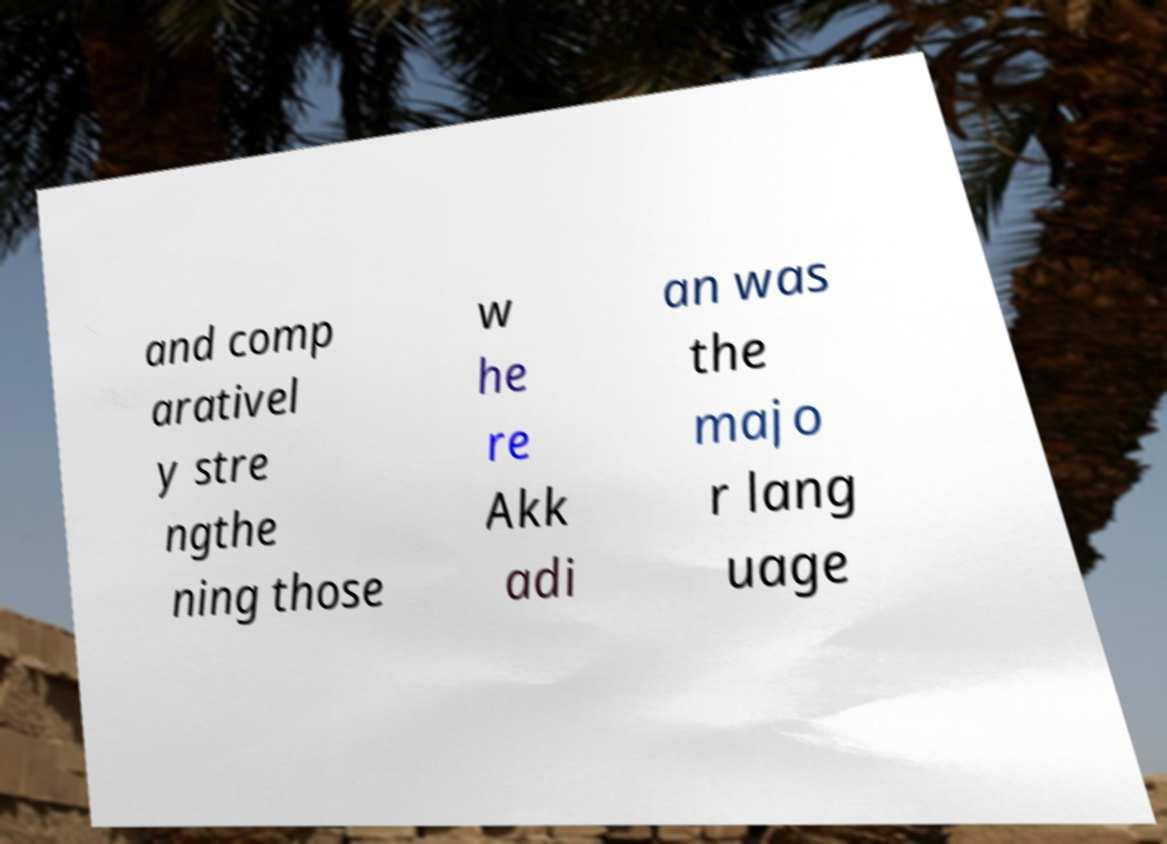I need the written content from this picture converted into text. Can you do that? and comp arativel y stre ngthe ning those w he re Akk adi an was the majo r lang uage 